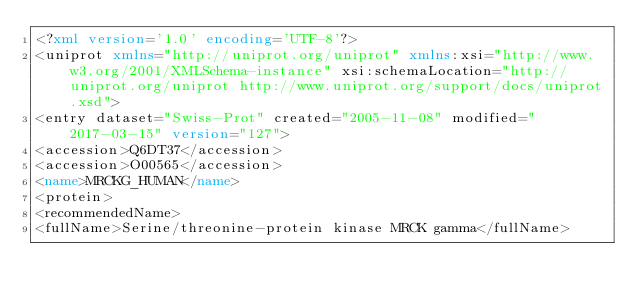<code> <loc_0><loc_0><loc_500><loc_500><_XML_><?xml version='1.0' encoding='UTF-8'?>
<uniprot xmlns="http://uniprot.org/uniprot" xmlns:xsi="http://www.w3.org/2001/XMLSchema-instance" xsi:schemaLocation="http://uniprot.org/uniprot http://www.uniprot.org/support/docs/uniprot.xsd">
<entry dataset="Swiss-Prot" created="2005-11-08" modified="2017-03-15" version="127">
<accession>Q6DT37</accession>
<accession>O00565</accession>
<name>MRCKG_HUMAN</name>
<protein>
<recommendedName>
<fullName>Serine/threonine-protein kinase MRCK gamma</fullName></code> 